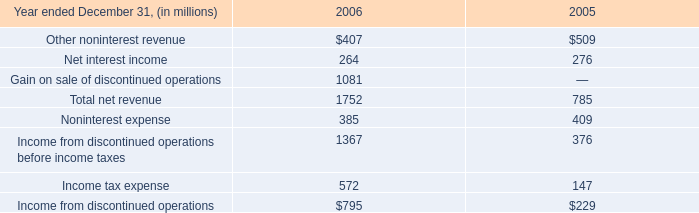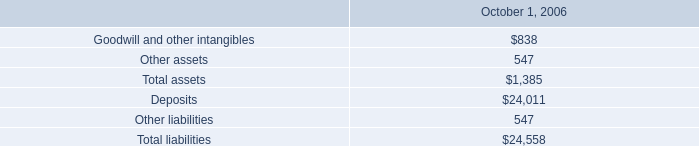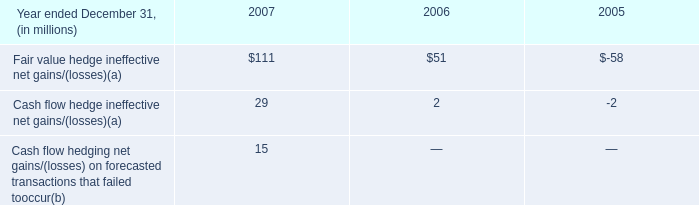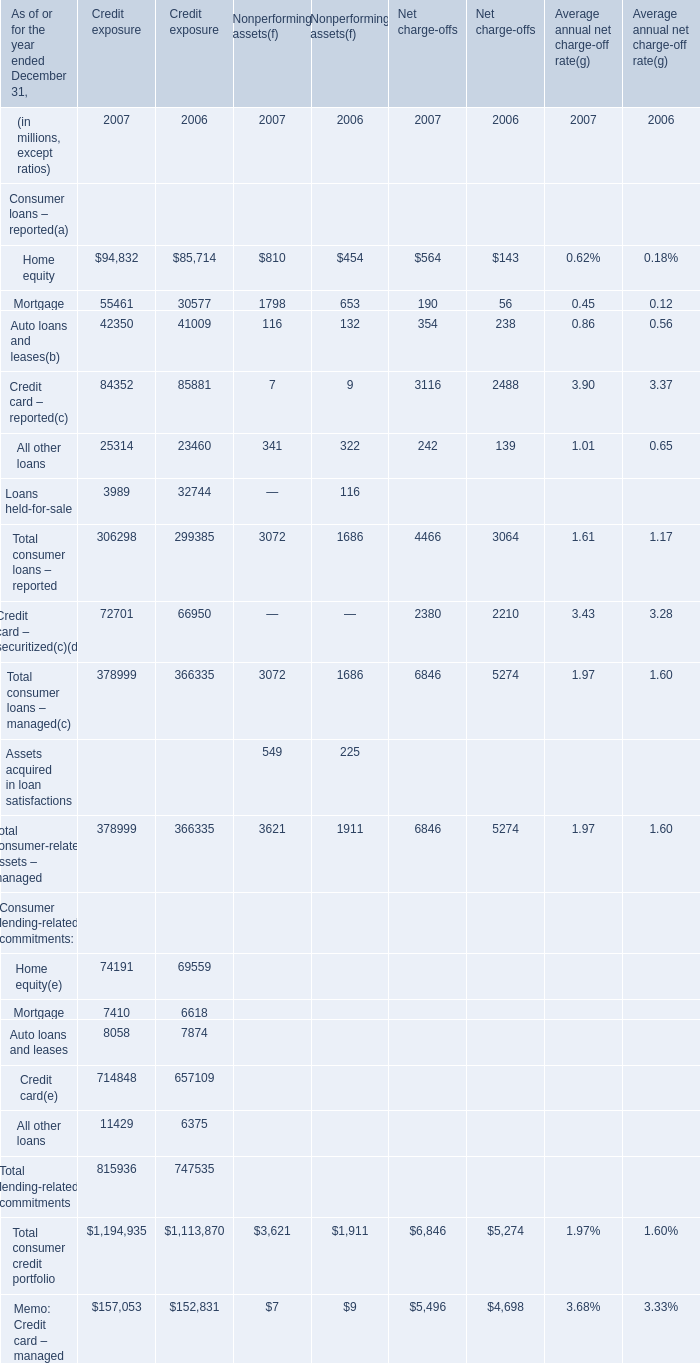What is the sum of Mortgage of Credit exposure 2007, Income from discontinued operations before income taxes of 2006, and Total consumer loans – managed of Nonperforming assets 2006 ? 
Computations: ((55461.0 + 1367.0) + 1686.0)
Answer: 58514.0. 